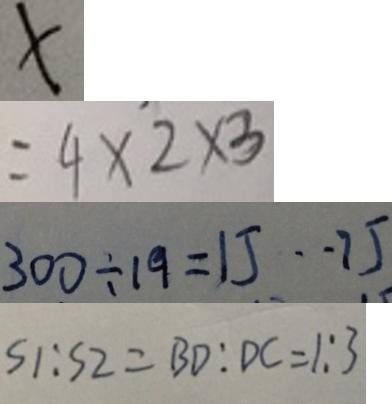Convert formula to latex. <formula><loc_0><loc_0><loc_500><loc_500>x 
 = 4 \times 2 \times 3 
 3 0 0 \div 1 9 = 1 5 \cdot 7 5 
 S 1 : S 2 = B D : D C = 1 : 3</formula> 